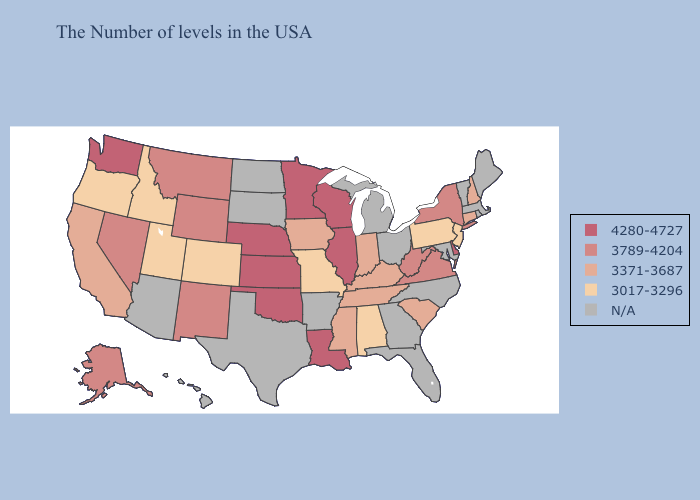Name the states that have a value in the range N/A?
Concise answer only. Maine, Massachusetts, Rhode Island, Vermont, Maryland, North Carolina, Ohio, Florida, Georgia, Michigan, Arkansas, Texas, South Dakota, North Dakota, Arizona, Hawaii. Name the states that have a value in the range 4280-4727?
Quick response, please. Delaware, Wisconsin, Illinois, Louisiana, Minnesota, Kansas, Nebraska, Oklahoma, Washington. What is the highest value in the USA?
Short answer required. 4280-4727. Does the first symbol in the legend represent the smallest category?
Short answer required. No. What is the value of Oregon?
Write a very short answer. 3017-3296. What is the value of Minnesota?
Concise answer only. 4280-4727. What is the lowest value in states that border North Carolina?
Be succinct. 3371-3687. Name the states that have a value in the range 3017-3296?
Quick response, please. New Jersey, Pennsylvania, Alabama, Missouri, Colorado, Utah, Idaho, Oregon. Is the legend a continuous bar?
Write a very short answer. No. Among the states that border Florida , which have the highest value?
Be succinct. Alabama. What is the value of South Dakota?
Short answer required. N/A. 